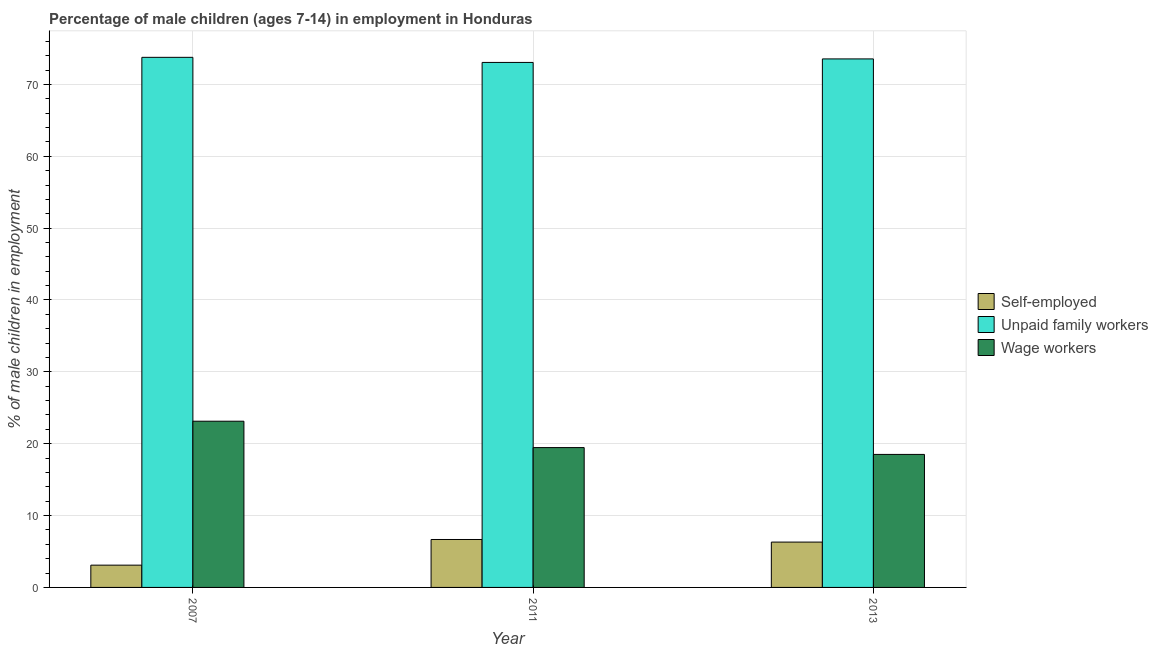What is the label of the 2nd group of bars from the left?
Offer a very short reply. 2011. In how many cases, is the number of bars for a given year not equal to the number of legend labels?
Offer a terse response. 0. What is the percentage of children employed as wage workers in 2007?
Provide a succinct answer. 23.13. Across all years, what is the maximum percentage of self employed children?
Your response must be concise. 6.67. In which year was the percentage of children employed as wage workers maximum?
Your answer should be very brief. 2007. In which year was the percentage of children employed as unpaid family workers minimum?
Keep it short and to the point. 2011. What is the total percentage of self employed children in the graph?
Your answer should be very brief. 16.08. What is the difference between the percentage of self employed children in 2007 and that in 2013?
Your response must be concise. -3.21. What is the difference between the percentage of self employed children in 2011 and the percentage of children employed as unpaid family workers in 2013?
Make the answer very short. 0.36. What is the average percentage of self employed children per year?
Give a very brief answer. 5.36. In how many years, is the percentage of children employed as wage workers greater than 44 %?
Give a very brief answer. 0. What is the ratio of the percentage of self employed children in 2011 to that in 2013?
Keep it short and to the point. 1.06. Is the percentage of children employed as wage workers in 2011 less than that in 2013?
Your answer should be very brief. No. What is the difference between the highest and the second highest percentage of children employed as wage workers?
Give a very brief answer. 3.67. What is the difference between the highest and the lowest percentage of children employed as unpaid family workers?
Ensure brevity in your answer.  0.71. Is the sum of the percentage of children employed as wage workers in 2007 and 2013 greater than the maximum percentage of children employed as unpaid family workers across all years?
Your answer should be very brief. Yes. What does the 3rd bar from the left in 2013 represents?
Offer a very short reply. Wage workers. What does the 3rd bar from the right in 2007 represents?
Offer a very short reply. Self-employed. Are all the bars in the graph horizontal?
Provide a short and direct response. No. How many years are there in the graph?
Ensure brevity in your answer.  3. What is the difference between two consecutive major ticks on the Y-axis?
Your response must be concise. 10. Does the graph contain any zero values?
Offer a terse response. No. Does the graph contain grids?
Make the answer very short. Yes. How are the legend labels stacked?
Provide a short and direct response. Vertical. What is the title of the graph?
Your answer should be very brief. Percentage of male children (ages 7-14) in employment in Honduras. Does "Methane" appear as one of the legend labels in the graph?
Provide a short and direct response. No. What is the label or title of the X-axis?
Ensure brevity in your answer.  Year. What is the label or title of the Y-axis?
Your answer should be very brief. % of male children in employment. What is the % of male children in employment in Unpaid family workers in 2007?
Provide a succinct answer. 73.77. What is the % of male children in employment of Wage workers in 2007?
Your response must be concise. 23.13. What is the % of male children in employment in Self-employed in 2011?
Your answer should be very brief. 6.67. What is the % of male children in employment in Unpaid family workers in 2011?
Offer a terse response. 73.06. What is the % of male children in employment of Wage workers in 2011?
Make the answer very short. 19.46. What is the % of male children in employment of Self-employed in 2013?
Ensure brevity in your answer.  6.31. What is the % of male children in employment in Unpaid family workers in 2013?
Provide a short and direct response. 73.55. What is the % of male children in employment of Wage workers in 2013?
Ensure brevity in your answer.  18.51. Across all years, what is the maximum % of male children in employment in Self-employed?
Your answer should be very brief. 6.67. Across all years, what is the maximum % of male children in employment in Unpaid family workers?
Provide a succinct answer. 73.77. Across all years, what is the maximum % of male children in employment of Wage workers?
Provide a short and direct response. 23.13. Across all years, what is the minimum % of male children in employment in Unpaid family workers?
Your answer should be very brief. 73.06. Across all years, what is the minimum % of male children in employment in Wage workers?
Your answer should be very brief. 18.51. What is the total % of male children in employment in Self-employed in the graph?
Provide a succinct answer. 16.08. What is the total % of male children in employment of Unpaid family workers in the graph?
Offer a very short reply. 220.38. What is the total % of male children in employment of Wage workers in the graph?
Provide a short and direct response. 61.1. What is the difference between the % of male children in employment in Self-employed in 2007 and that in 2011?
Offer a terse response. -3.57. What is the difference between the % of male children in employment in Unpaid family workers in 2007 and that in 2011?
Provide a short and direct response. 0.71. What is the difference between the % of male children in employment of Wage workers in 2007 and that in 2011?
Your answer should be very brief. 3.67. What is the difference between the % of male children in employment in Self-employed in 2007 and that in 2013?
Make the answer very short. -3.21. What is the difference between the % of male children in employment of Unpaid family workers in 2007 and that in 2013?
Your response must be concise. 0.22. What is the difference between the % of male children in employment in Wage workers in 2007 and that in 2013?
Provide a short and direct response. 4.62. What is the difference between the % of male children in employment in Self-employed in 2011 and that in 2013?
Offer a terse response. 0.36. What is the difference between the % of male children in employment of Unpaid family workers in 2011 and that in 2013?
Offer a very short reply. -0.49. What is the difference between the % of male children in employment in Wage workers in 2011 and that in 2013?
Your answer should be compact. 0.95. What is the difference between the % of male children in employment in Self-employed in 2007 and the % of male children in employment in Unpaid family workers in 2011?
Give a very brief answer. -69.96. What is the difference between the % of male children in employment of Self-employed in 2007 and the % of male children in employment of Wage workers in 2011?
Ensure brevity in your answer.  -16.36. What is the difference between the % of male children in employment of Unpaid family workers in 2007 and the % of male children in employment of Wage workers in 2011?
Ensure brevity in your answer.  54.31. What is the difference between the % of male children in employment of Self-employed in 2007 and the % of male children in employment of Unpaid family workers in 2013?
Ensure brevity in your answer.  -70.45. What is the difference between the % of male children in employment in Self-employed in 2007 and the % of male children in employment in Wage workers in 2013?
Offer a terse response. -15.41. What is the difference between the % of male children in employment of Unpaid family workers in 2007 and the % of male children in employment of Wage workers in 2013?
Offer a very short reply. 55.26. What is the difference between the % of male children in employment in Self-employed in 2011 and the % of male children in employment in Unpaid family workers in 2013?
Ensure brevity in your answer.  -66.88. What is the difference between the % of male children in employment in Self-employed in 2011 and the % of male children in employment in Wage workers in 2013?
Your answer should be compact. -11.84. What is the difference between the % of male children in employment in Unpaid family workers in 2011 and the % of male children in employment in Wage workers in 2013?
Your answer should be compact. 54.55. What is the average % of male children in employment in Self-employed per year?
Provide a short and direct response. 5.36. What is the average % of male children in employment of Unpaid family workers per year?
Provide a succinct answer. 73.46. What is the average % of male children in employment of Wage workers per year?
Provide a short and direct response. 20.37. In the year 2007, what is the difference between the % of male children in employment of Self-employed and % of male children in employment of Unpaid family workers?
Provide a short and direct response. -70.67. In the year 2007, what is the difference between the % of male children in employment in Self-employed and % of male children in employment in Wage workers?
Ensure brevity in your answer.  -20.03. In the year 2007, what is the difference between the % of male children in employment in Unpaid family workers and % of male children in employment in Wage workers?
Keep it short and to the point. 50.64. In the year 2011, what is the difference between the % of male children in employment of Self-employed and % of male children in employment of Unpaid family workers?
Your answer should be compact. -66.39. In the year 2011, what is the difference between the % of male children in employment in Self-employed and % of male children in employment in Wage workers?
Keep it short and to the point. -12.79. In the year 2011, what is the difference between the % of male children in employment of Unpaid family workers and % of male children in employment of Wage workers?
Ensure brevity in your answer.  53.6. In the year 2013, what is the difference between the % of male children in employment of Self-employed and % of male children in employment of Unpaid family workers?
Keep it short and to the point. -67.24. In the year 2013, what is the difference between the % of male children in employment of Self-employed and % of male children in employment of Wage workers?
Give a very brief answer. -12.2. In the year 2013, what is the difference between the % of male children in employment of Unpaid family workers and % of male children in employment of Wage workers?
Your answer should be very brief. 55.04. What is the ratio of the % of male children in employment of Self-employed in 2007 to that in 2011?
Offer a very short reply. 0.46. What is the ratio of the % of male children in employment in Unpaid family workers in 2007 to that in 2011?
Offer a very short reply. 1.01. What is the ratio of the % of male children in employment of Wage workers in 2007 to that in 2011?
Keep it short and to the point. 1.19. What is the ratio of the % of male children in employment in Self-employed in 2007 to that in 2013?
Provide a short and direct response. 0.49. What is the ratio of the % of male children in employment of Wage workers in 2007 to that in 2013?
Keep it short and to the point. 1.25. What is the ratio of the % of male children in employment in Self-employed in 2011 to that in 2013?
Provide a succinct answer. 1.06. What is the ratio of the % of male children in employment of Wage workers in 2011 to that in 2013?
Provide a short and direct response. 1.05. What is the difference between the highest and the second highest % of male children in employment in Self-employed?
Provide a short and direct response. 0.36. What is the difference between the highest and the second highest % of male children in employment in Unpaid family workers?
Keep it short and to the point. 0.22. What is the difference between the highest and the second highest % of male children in employment of Wage workers?
Give a very brief answer. 3.67. What is the difference between the highest and the lowest % of male children in employment of Self-employed?
Your response must be concise. 3.57. What is the difference between the highest and the lowest % of male children in employment in Unpaid family workers?
Your answer should be very brief. 0.71. What is the difference between the highest and the lowest % of male children in employment in Wage workers?
Your answer should be very brief. 4.62. 